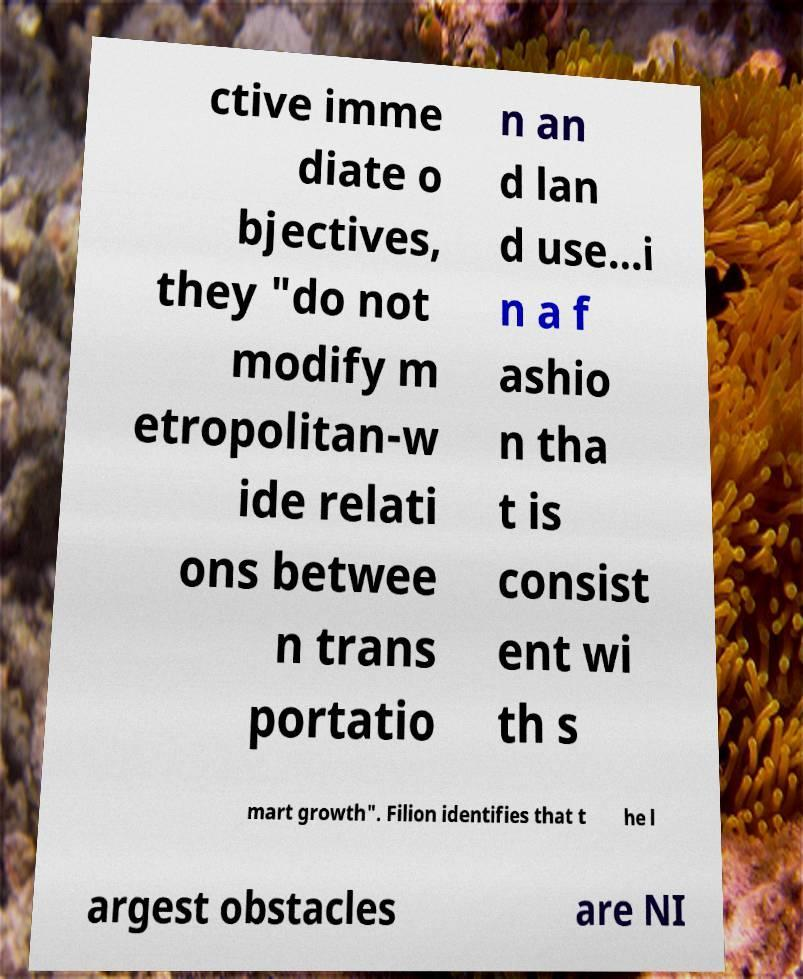Could you assist in decoding the text presented in this image and type it out clearly? ctive imme diate o bjectives, they "do not modify m etropolitan-w ide relati ons betwee n trans portatio n an d lan d use...i n a f ashio n tha t is consist ent wi th s mart growth". Filion identifies that t he l argest obstacles are NI 